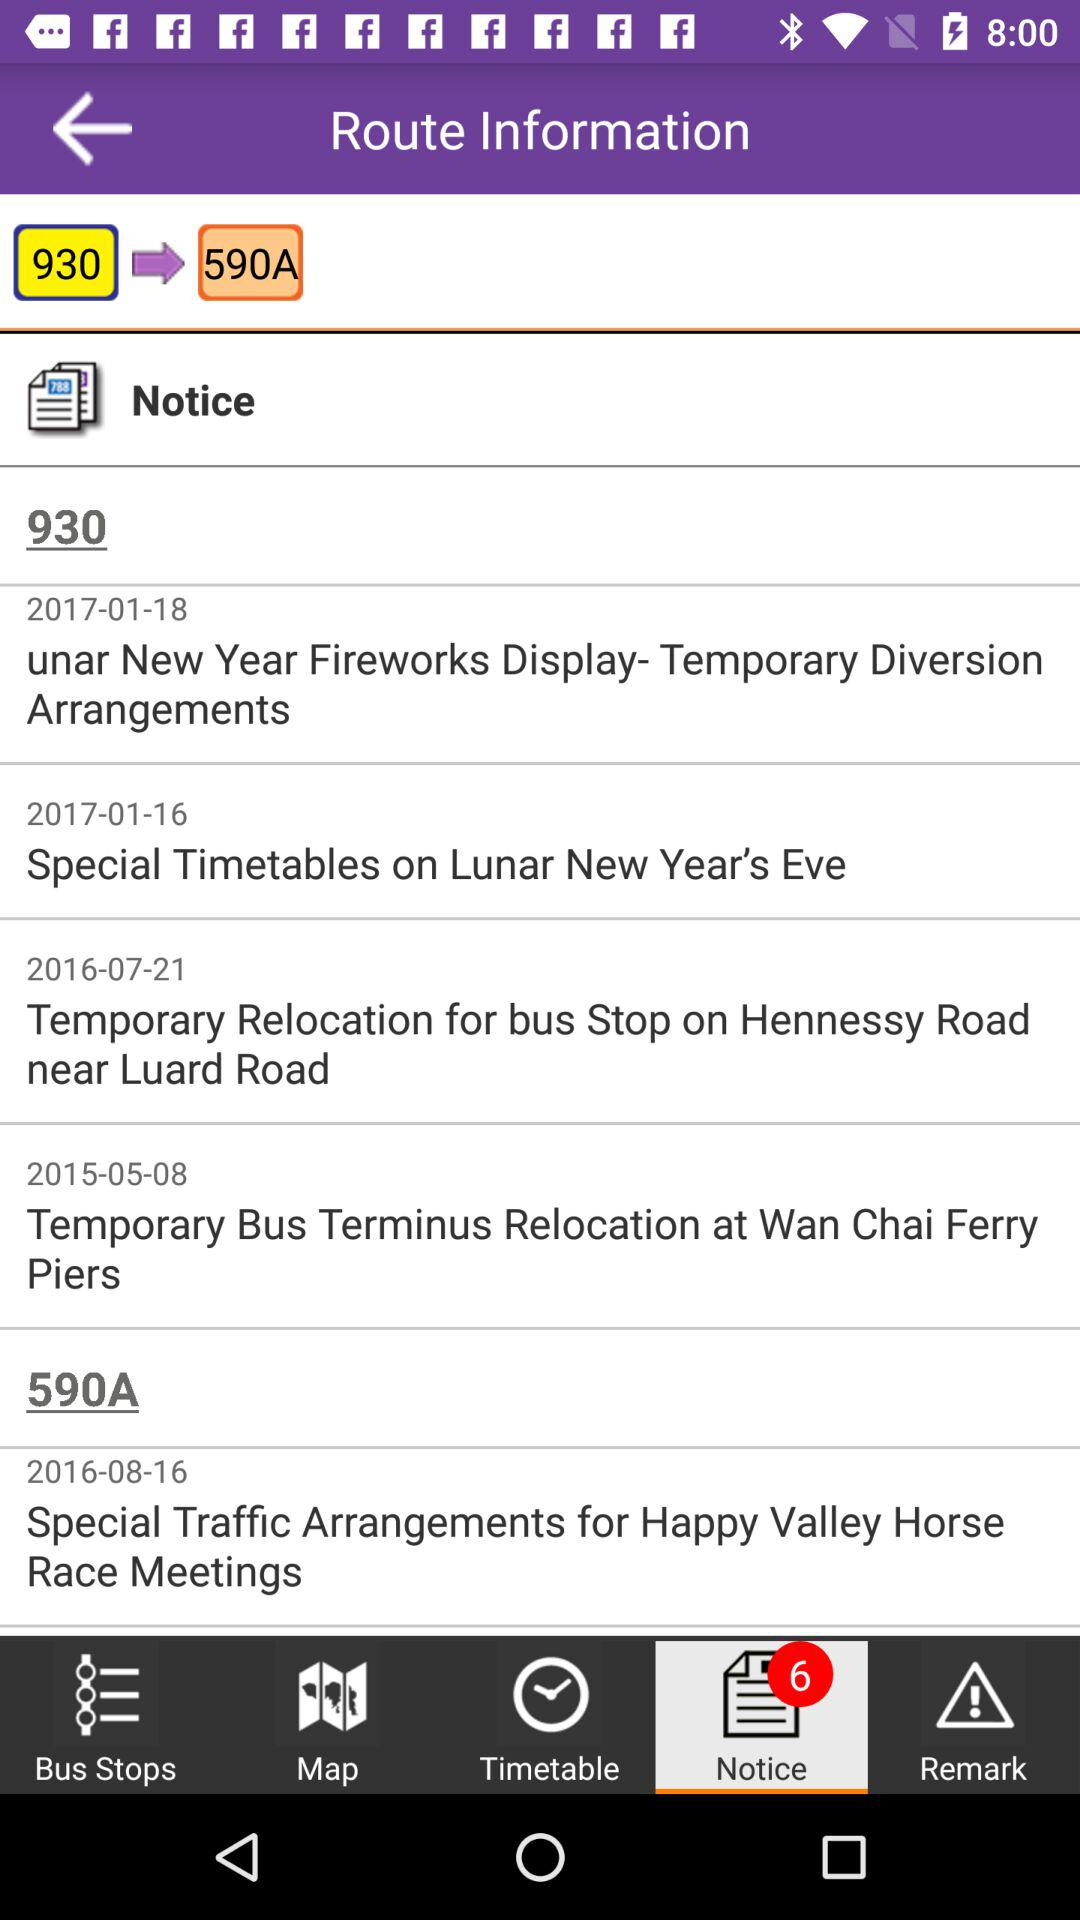Which tab am I on? You are at "Notice" tab. 